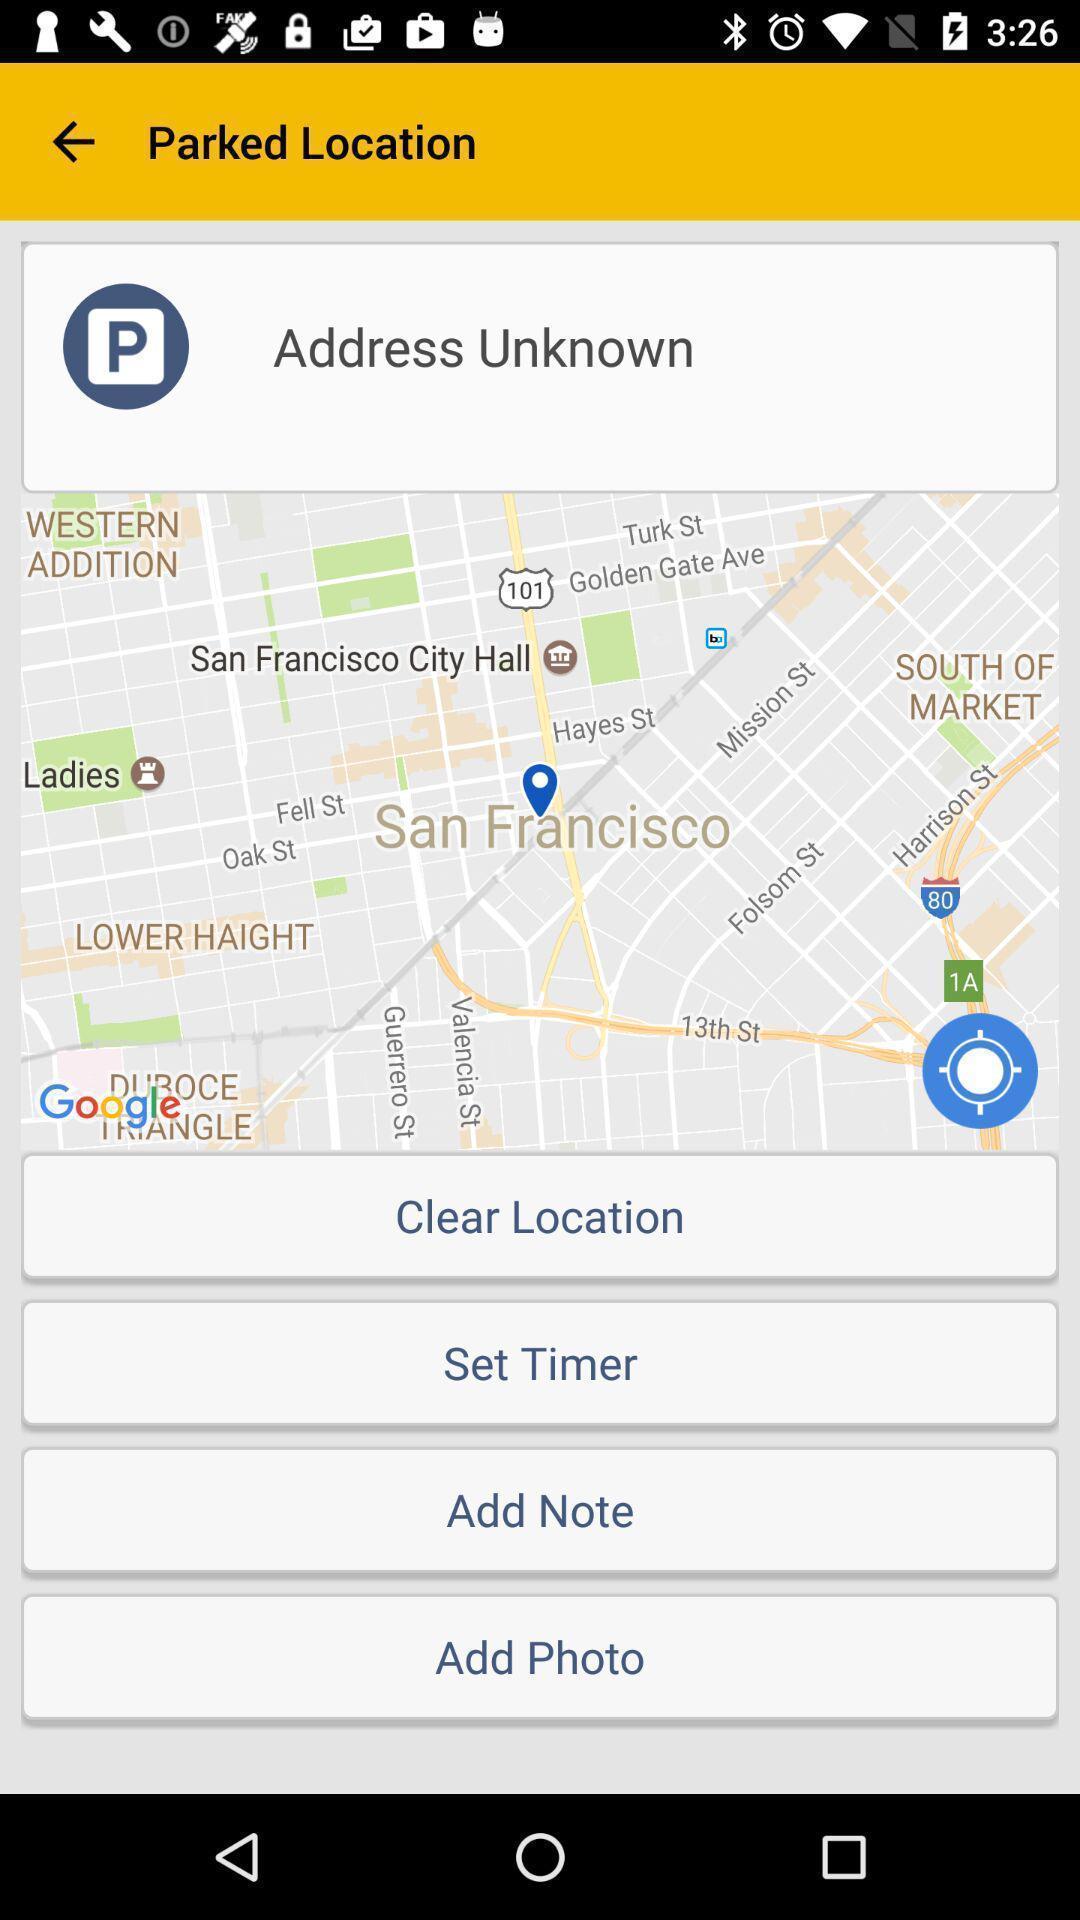What is the overall content of this screenshot? Parked location page with different options in vehicle assistance app. 